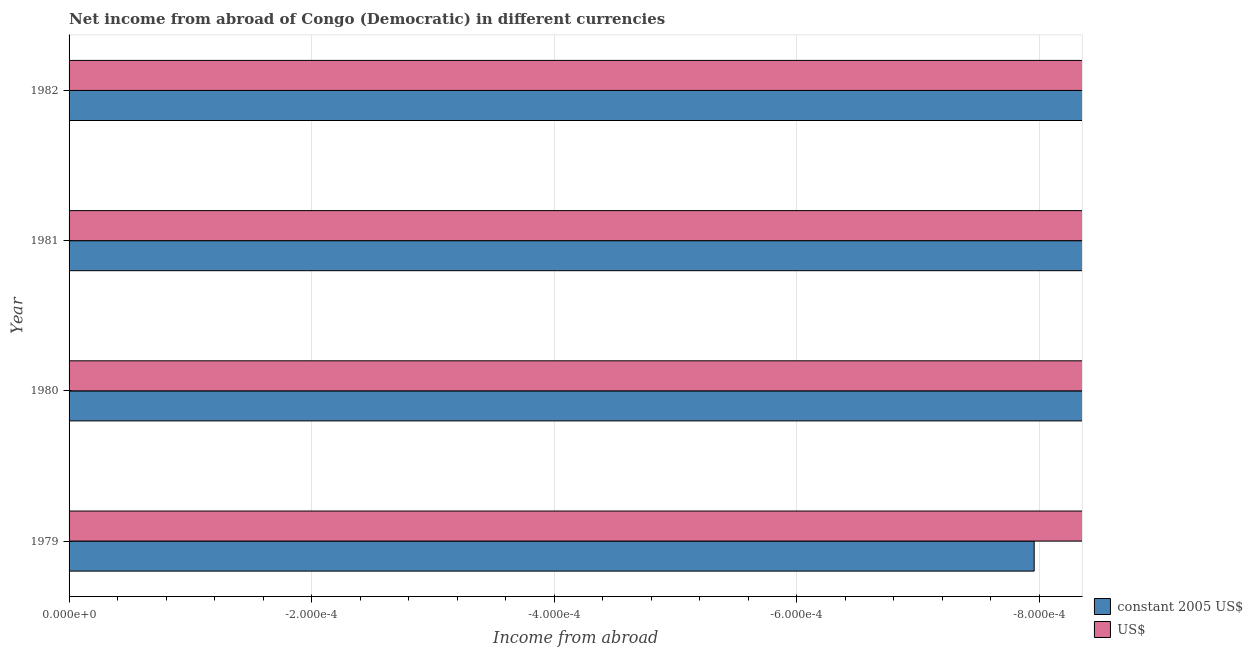Are the number of bars on each tick of the Y-axis equal?
Your answer should be very brief. Yes. What is the label of the 1st group of bars from the top?
Ensure brevity in your answer.  1982. Across all years, what is the minimum income from abroad in us$?
Ensure brevity in your answer.  0. What is the total income from abroad in us$ in the graph?
Your response must be concise. 0. In how many years, is the income from abroad in us$ greater than -0.0005200000000000001 units?
Keep it short and to the point. 0. In how many years, is the income from abroad in constant 2005 us$ greater than the average income from abroad in constant 2005 us$ taken over all years?
Offer a very short reply. 0. How many bars are there?
Make the answer very short. 0. Are all the bars in the graph horizontal?
Keep it short and to the point. Yes. How many years are there in the graph?
Ensure brevity in your answer.  4. What is the difference between two consecutive major ticks on the X-axis?
Your answer should be very brief. 0. Are the values on the major ticks of X-axis written in scientific E-notation?
Your response must be concise. Yes. Does the graph contain any zero values?
Ensure brevity in your answer.  Yes. Does the graph contain grids?
Make the answer very short. Yes. Where does the legend appear in the graph?
Your response must be concise. Bottom right. How many legend labels are there?
Make the answer very short. 2. How are the legend labels stacked?
Your answer should be compact. Vertical. What is the title of the graph?
Provide a short and direct response. Net income from abroad of Congo (Democratic) in different currencies. What is the label or title of the X-axis?
Provide a succinct answer. Income from abroad. What is the Income from abroad in constant 2005 US$ in 1979?
Offer a terse response. 0. What is the Income from abroad of US$ in 1981?
Make the answer very short. 0. What is the Income from abroad in constant 2005 US$ in 1982?
Your answer should be very brief. 0. What is the Income from abroad in US$ in 1982?
Make the answer very short. 0. What is the total Income from abroad of constant 2005 US$ in the graph?
Ensure brevity in your answer.  0. 